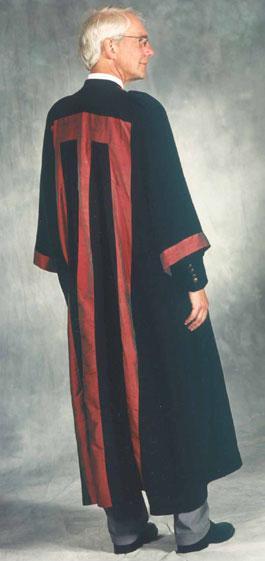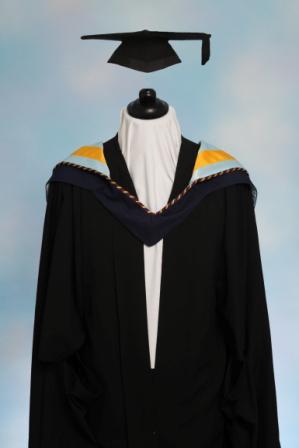The first image is the image on the left, the second image is the image on the right. Examine the images to the left and right. Is the description "One image contains at least one living young male model." accurate? Answer yes or no. No. The first image is the image on the left, the second image is the image on the right. For the images displayed, is the sentence "There is one an wearing a graduation gown" factually correct? Answer yes or no. Yes. 